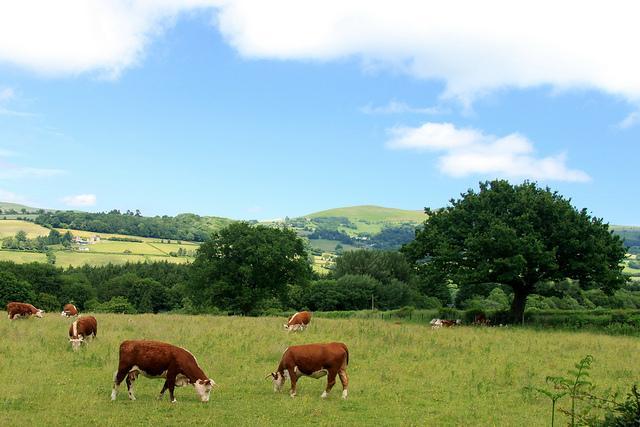These animals usually live where? farm 